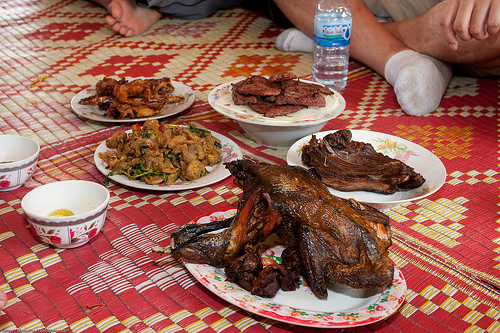<image>
Can you confirm if the meat is on the blanket? No. The meat is not positioned on the blanket. They may be near each other, but the meat is not supported by or resting on top of the blanket. 